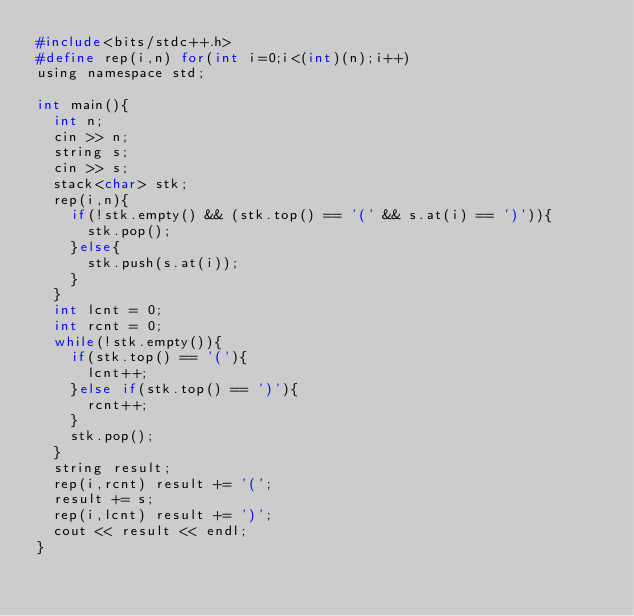Convert code to text. <code><loc_0><loc_0><loc_500><loc_500><_C_>#include<bits/stdc++.h>
#define rep(i,n) for(int i=0;i<(int)(n);i++)
using namespace std;

int main(){
  int n;
  cin >> n;
  string s;
  cin >> s;
  stack<char> stk;
  rep(i,n){
    if(!stk.empty() && (stk.top() == '(' && s.at(i) == ')')){
      stk.pop();
    }else{
      stk.push(s.at(i));
    }
  }
  int lcnt = 0;
  int rcnt = 0;
  while(!stk.empty()){
    if(stk.top() == '('){
      lcnt++;
    }else if(stk.top() == ')'){
      rcnt++;
    }
    stk.pop();
  }
  string result;
  rep(i,rcnt) result += '(';
  result += s;
  rep(i,lcnt) result += ')';
  cout << result << endl;
}</code> 